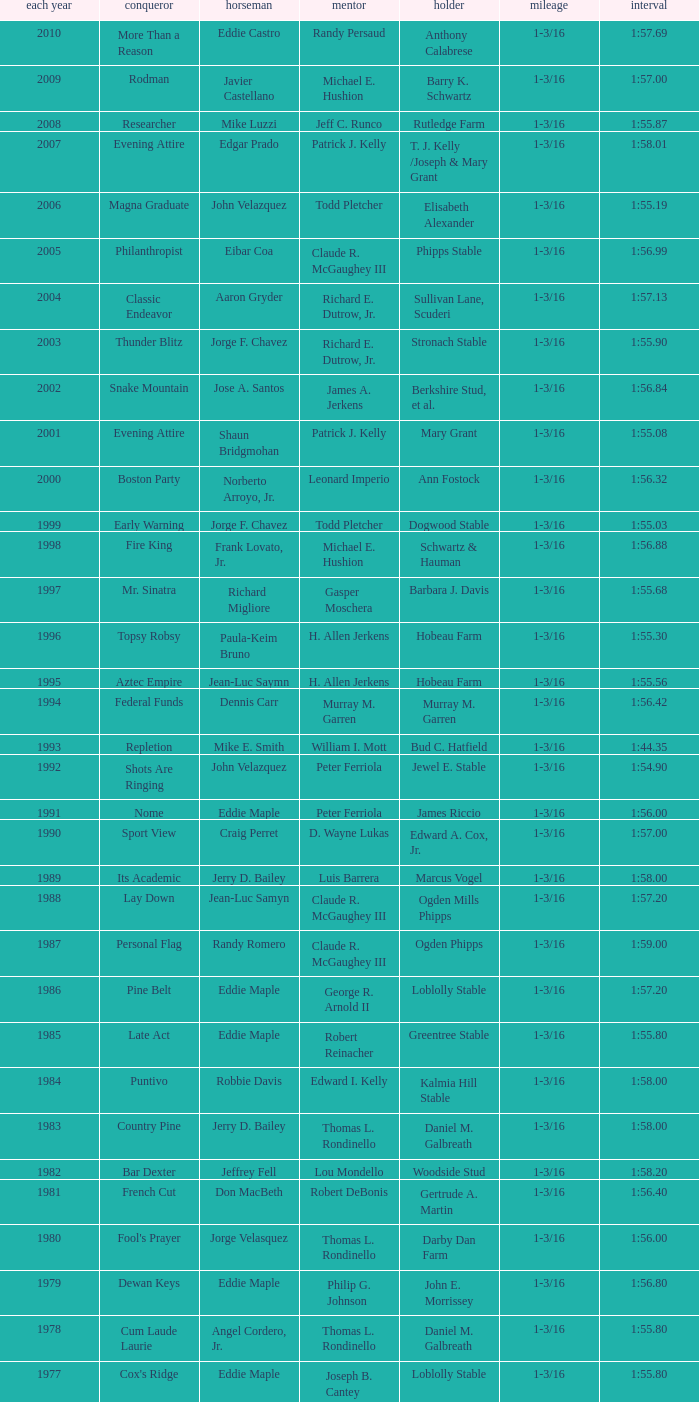What horse won with a trainer of "no race"? No Race, No Race, No Race, No Race. 